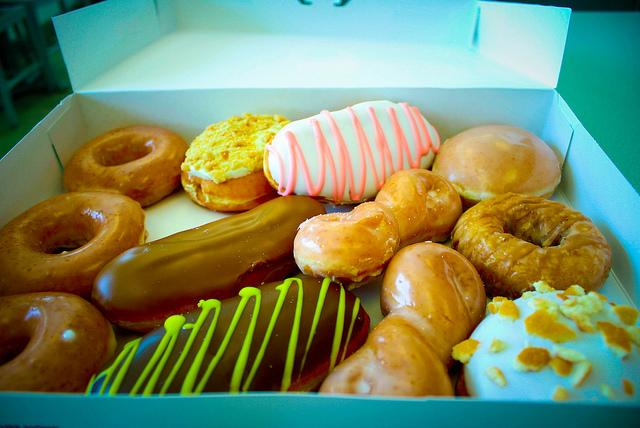What treat is in the box?

Choices:
A) gummy bears
B) donut
C) pizza
D) apple pie donut 